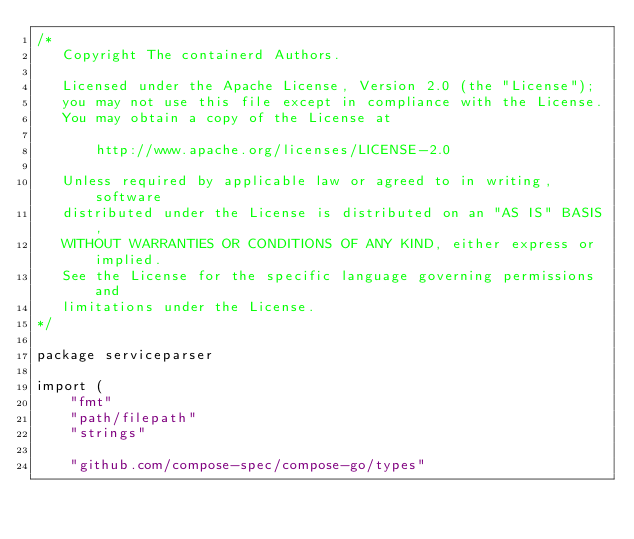<code> <loc_0><loc_0><loc_500><loc_500><_Go_>/*
   Copyright The containerd Authors.

   Licensed under the Apache License, Version 2.0 (the "License");
   you may not use this file except in compliance with the License.
   You may obtain a copy of the License at

       http://www.apache.org/licenses/LICENSE-2.0

   Unless required by applicable law or agreed to in writing, software
   distributed under the License is distributed on an "AS IS" BASIS,
   WITHOUT WARRANTIES OR CONDITIONS OF ANY KIND, either express or implied.
   See the License for the specific language governing permissions and
   limitations under the License.
*/

package serviceparser

import (
	"fmt"
	"path/filepath"
	"strings"

	"github.com/compose-spec/compose-go/types"</code> 